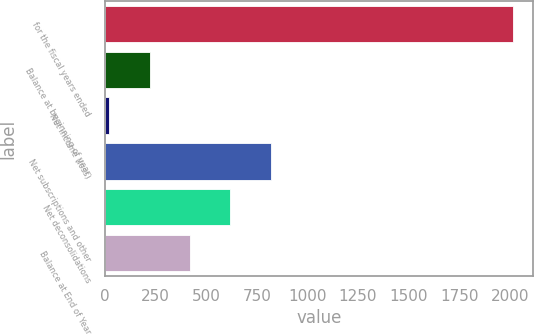Convert chart to OTSL. <chart><loc_0><loc_0><loc_500><loc_500><bar_chart><fcel>for the fiscal years ended<fcel>Balance at beginning of year<fcel>Net income (loss)<fcel>Net subscriptions and other<fcel>Net deconsolidations<fcel>Balance at End of Year<nl><fcel>2014<fcel>219.94<fcel>20.6<fcel>817.96<fcel>618.62<fcel>419.28<nl></chart> 